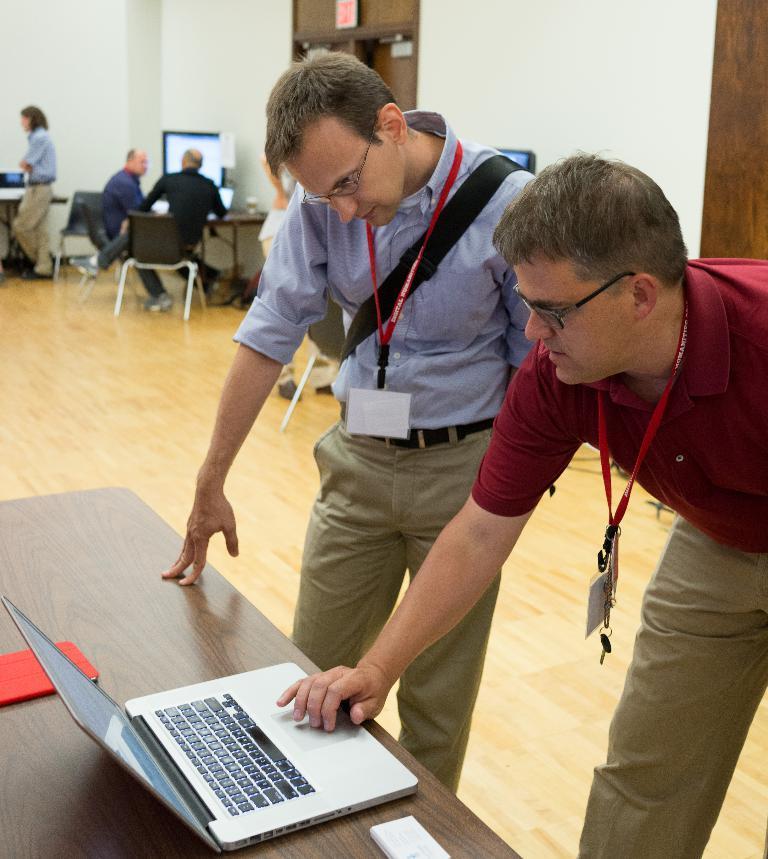How would you summarize this image in a sentence or two? This picture is clicked inside. On the right there is a person wearing red color t-shirt, standing on the ground and seems to be working on a laptop and there is another person wearing blue color shirt and standing on the ground and there are some objects placed on the table. In the background we can see the wall, door and group of persons sitting on the chairs and a person standing on the ground and we can see the tables on the top of which many number of items are placed. 